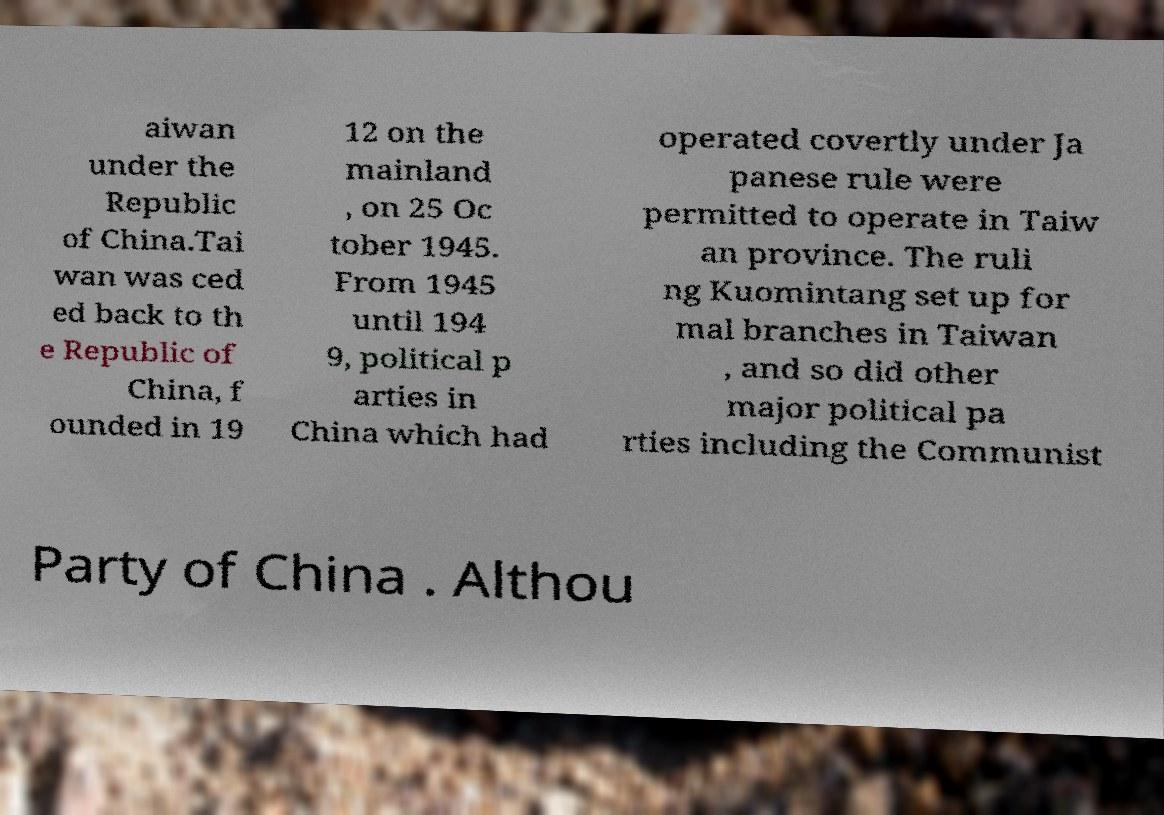There's text embedded in this image that I need extracted. Can you transcribe it verbatim? aiwan under the Republic of China.Tai wan was ced ed back to th e Republic of China, f ounded in 19 12 on the mainland , on 25 Oc tober 1945. From 1945 until 194 9, political p arties in China which had operated covertly under Ja panese rule were permitted to operate in Taiw an province. The ruli ng Kuomintang set up for mal branches in Taiwan , and so did other major political pa rties including the Communist Party of China . Althou 